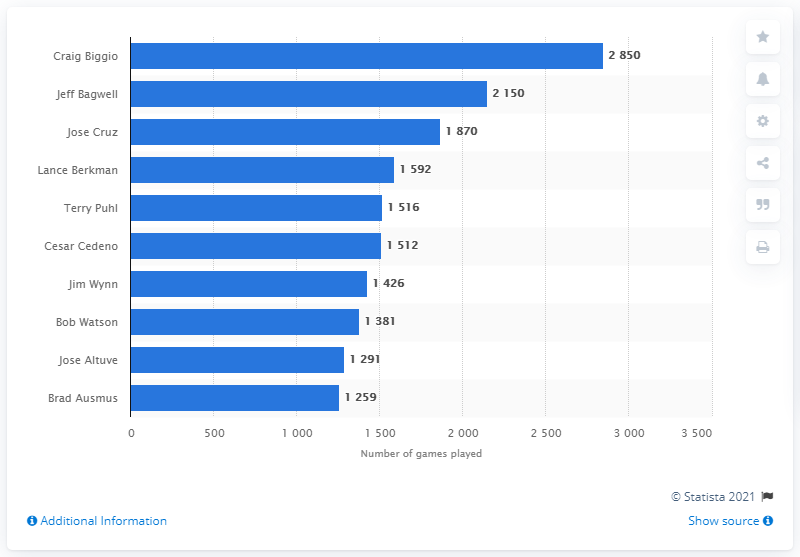Draw attention to some important aspects in this diagram. The Houston Astros franchise has had many outstanding players throughout its history, but none have played more games than Craig Biggio. Biggio, a former second baseman for the Astros, holds the record for the most games played in franchise history. 